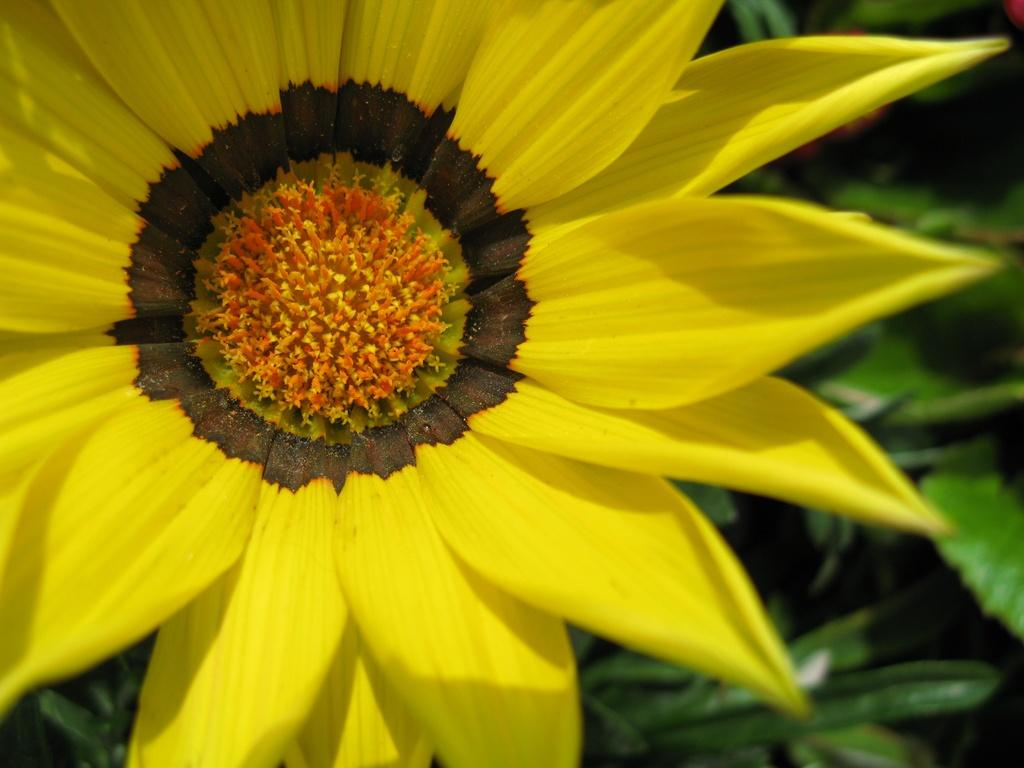What is the main subject of the image? There is a flower in the image. What can be seen behind the flower? There are leaves behind the flower in the image. What type of prose is written on the flower in the image? There is no prose written on the flower in the image; it is a photograph of a flower and leaves. 